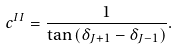<formula> <loc_0><loc_0><loc_500><loc_500>c ^ { I I } = \frac { 1 } { \tan \left ( \delta _ { J + 1 } - \delta _ { J - 1 } \right ) } .</formula> 